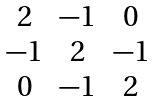<formula> <loc_0><loc_0><loc_500><loc_500>\begin{matrix} 2 & - 1 & 0 \\ - 1 & 2 & - 1 \\ 0 & - 1 & 2 \end{matrix}</formula> 